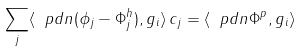<formula> <loc_0><loc_0><loc_500><loc_500>\sum _ { j } \langle \ p d n ( \phi _ { j } - \Phi ^ { h } _ { j } ) , g _ { i } \rangle \, c _ { j } = \langle \ p d n { \Phi ^ { p } } , g _ { i } \rangle</formula> 